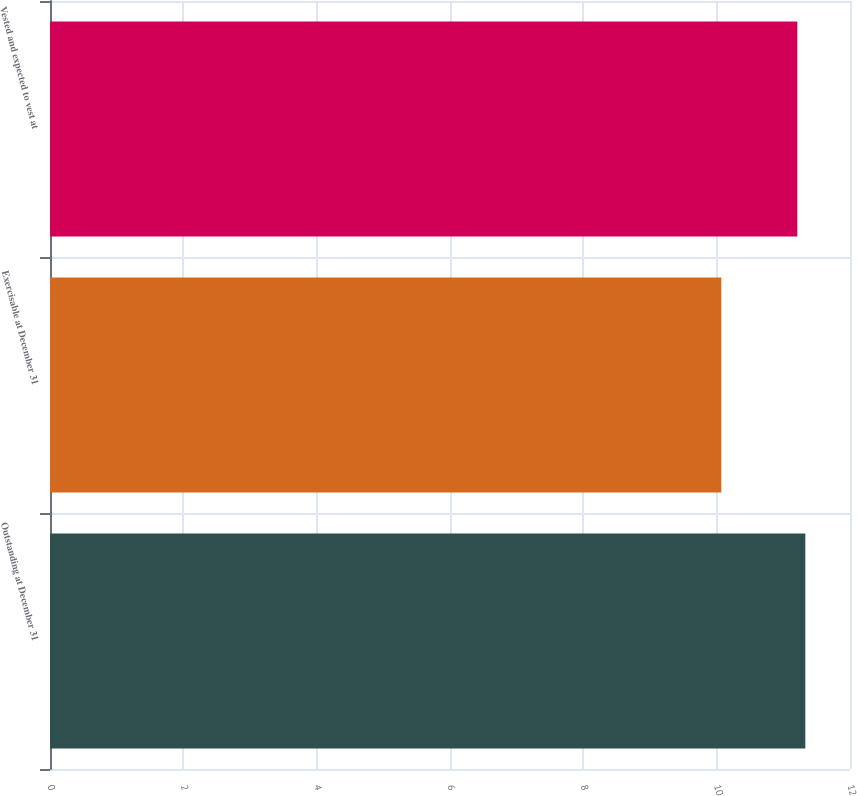Convert chart to OTSL. <chart><loc_0><loc_0><loc_500><loc_500><bar_chart><fcel>Outstanding at December 31<fcel>Exercisable at December 31<fcel>Vested and expected to vest at<nl><fcel>11.33<fcel>10.07<fcel>11.21<nl></chart> 